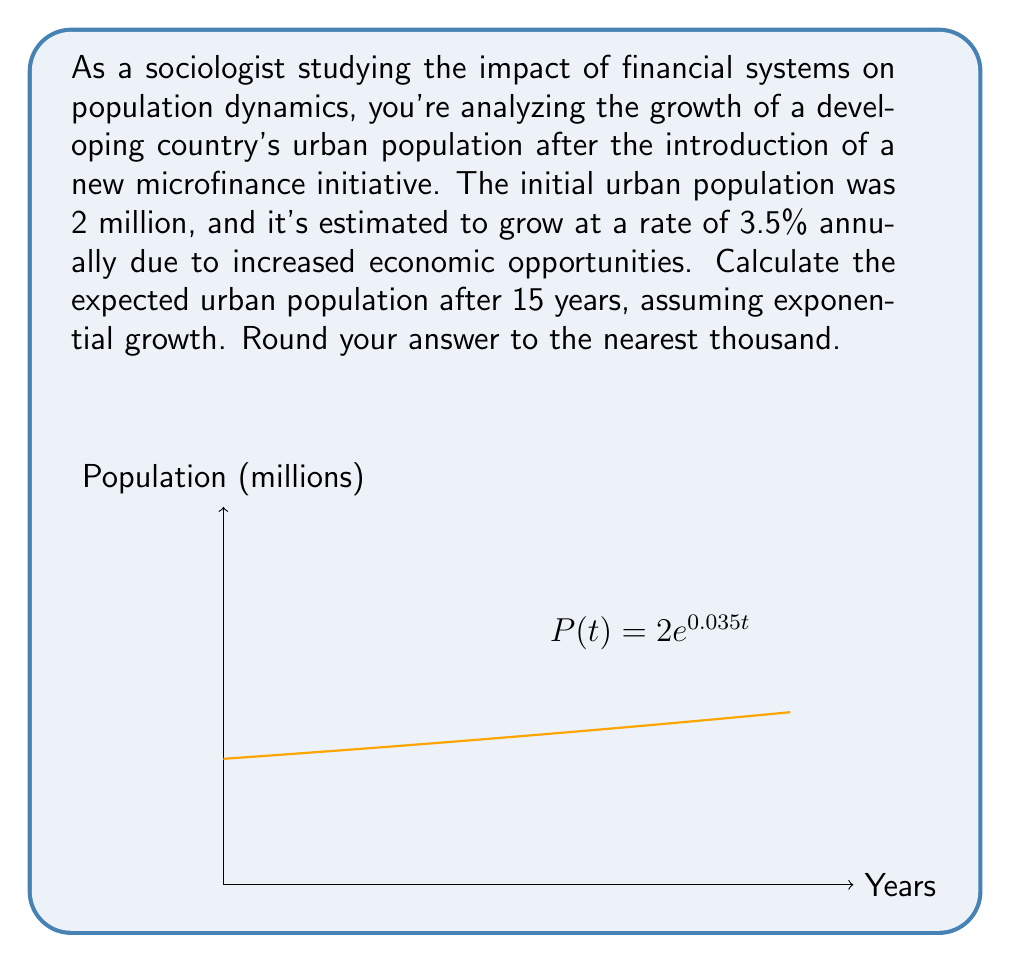Can you answer this question? To solve this problem, we'll use the exponential growth formula:

$$P(t) = P_0 \cdot e^{rt}$$

Where:
$P(t)$ is the population at time $t$
$P_0$ is the initial population
$r$ is the growth rate (as a decimal)
$t$ is the time in years
$e$ is Euler's number (approximately 2.71828)

Given:
$P_0 = 2$ million
$r = 3.5\% = 0.035$
$t = 15$ years

Let's substitute these values into the formula:

$$P(15) = 2 \cdot e^{0.035 \cdot 15}$$

Now, let's calculate:

1) First, compute the exponent: $0.035 \cdot 15 = 0.525$
2) Calculate $e^{0.525}$:
   $$e^{0.525} \approx 1.69065$$
3) Multiply by the initial population:
   $$2 \cdot 1.69065 \approx 3.3813$$

Therefore, the population after 15 years would be approximately 3.3813 million.

Rounding to the nearest thousand: 3,381,000
Answer: 3,381,000 